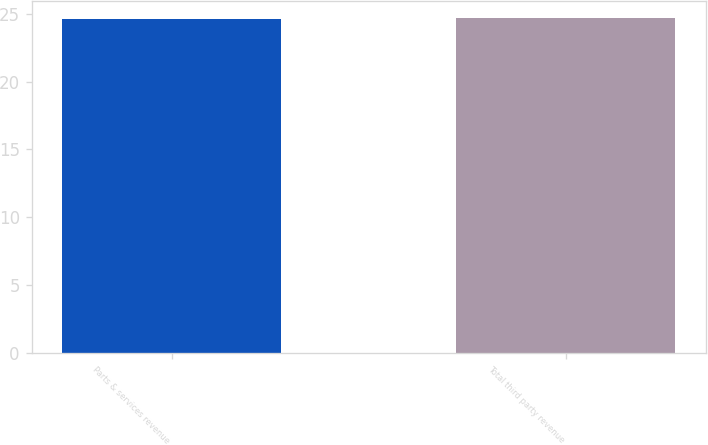Convert chart to OTSL. <chart><loc_0><loc_0><loc_500><loc_500><bar_chart><fcel>Parts & services revenue<fcel>Total third party revenue<nl><fcel>24.6<fcel>24.7<nl></chart> 